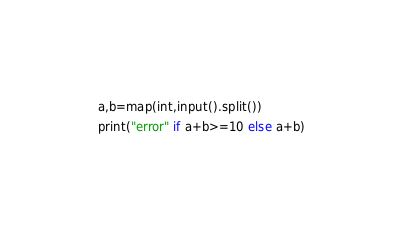Convert code to text. <code><loc_0><loc_0><loc_500><loc_500><_Python_>a,b=map(int,input().split())
print("error" if a+b>=10 else a+b)</code> 